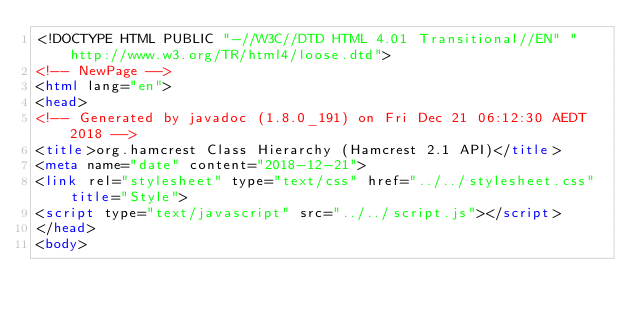Convert code to text. <code><loc_0><loc_0><loc_500><loc_500><_HTML_><!DOCTYPE HTML PUBLIC "-//W3C//DTD HTML 4.01 Transitional//EN" "http://www.w3.org/TR/html4/loose.dtd">
<!-- NewPage -->
<html lang="en">
<head>
<!-- Generated by javadoc (1.8.0_191) on Fri Dec 21 06:12:30 AEDT 2018 -->
<title>org.hamcrest Class Hierarchy (Hamcrest 2.1 API)</title>
<meta name="date" content="2018-12-21">
<link rel="stylesheet" type="text/css" href="../../stylesheet.css" title="Style">
<script type="text/javascript" src="../../script.js"></script>
</head>
<body></code> 